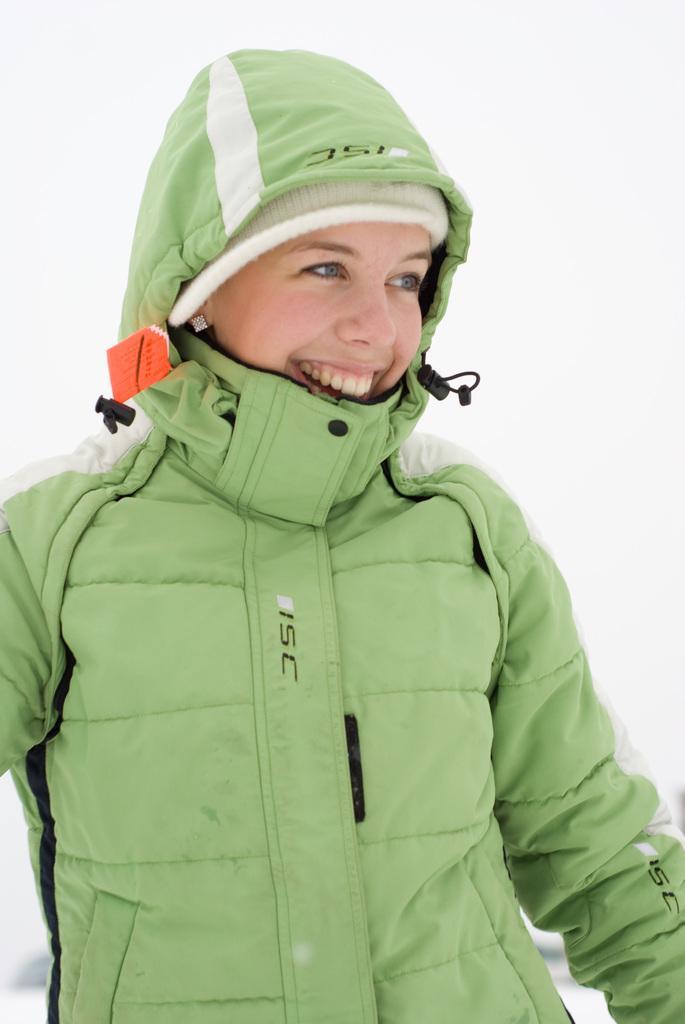How would you summarize this image in a sentence or two? Background portion of the picture is in white color. In this picture we can see a person wearing a jacket and a person is smiling. 